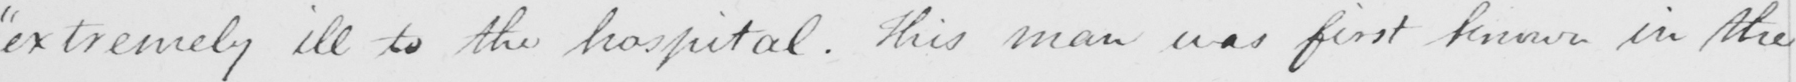What is written in this line of handwriting? " extremely ill to the hospital . This man was first known in the 